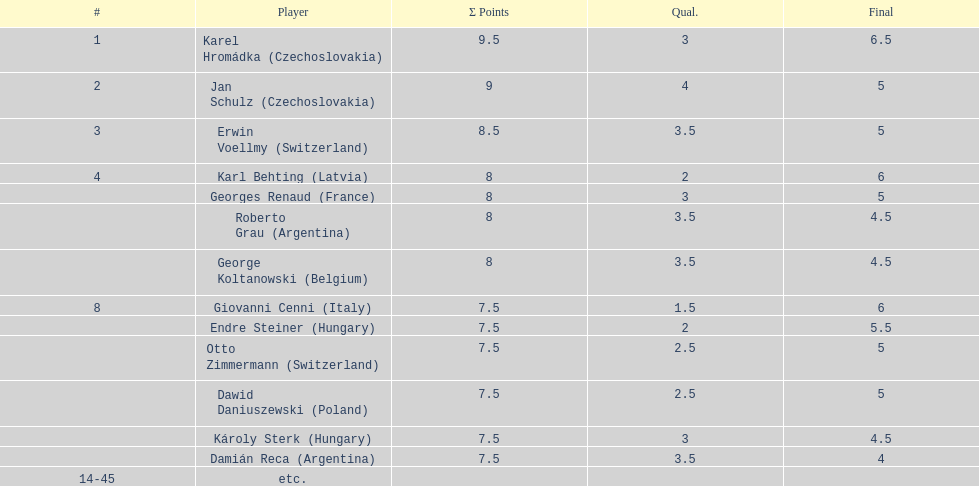How many countries featured more than a single player in the consolation cup? 4. 